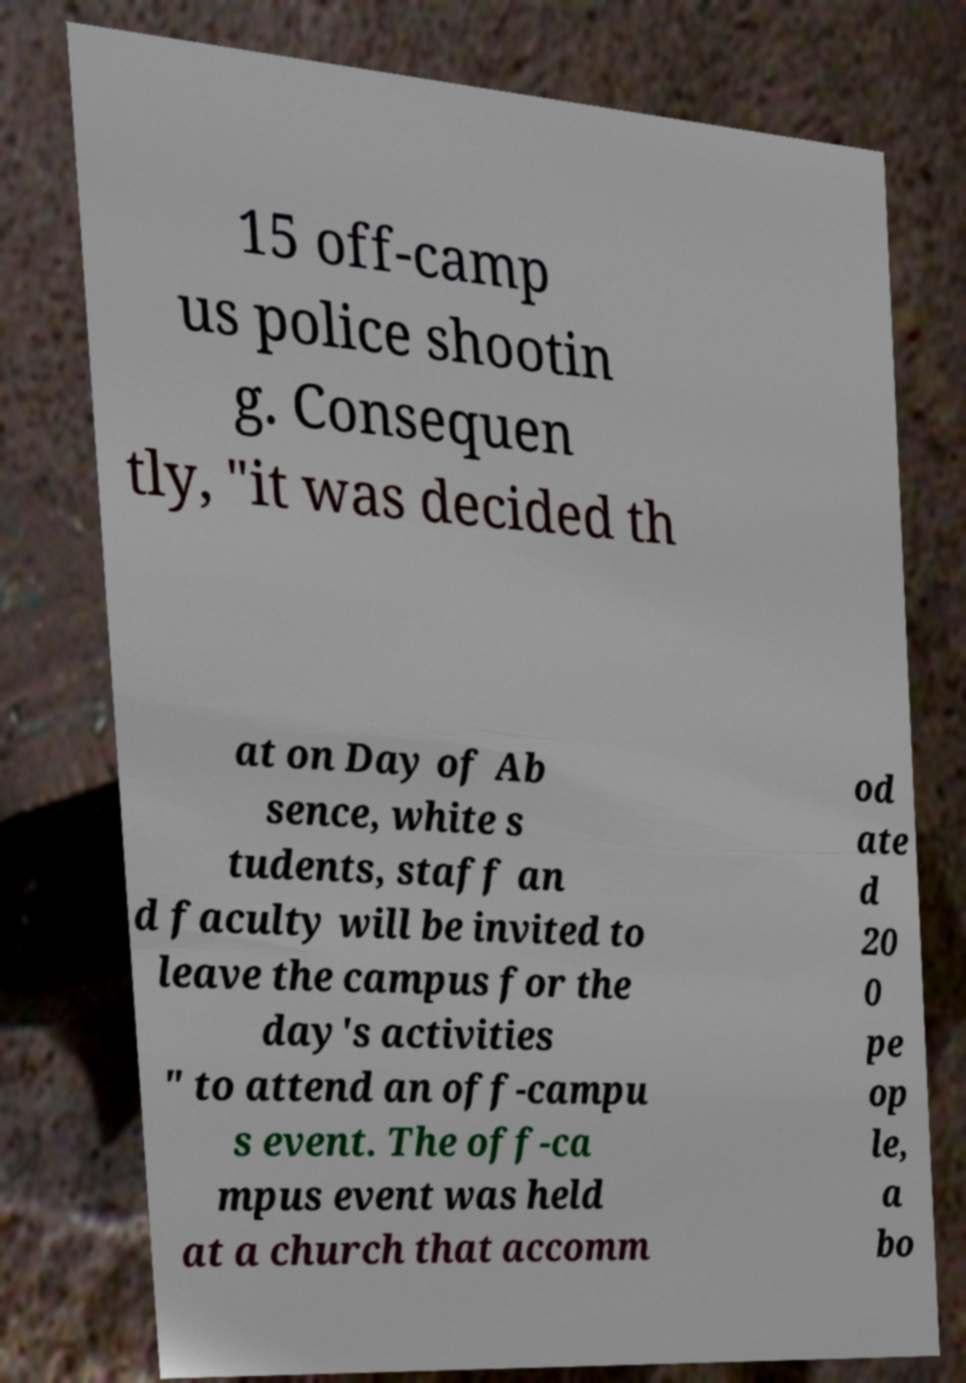I need the written content from this picture converted into text. Can you do that? 15 off-camp us police shootin g. Consequen tly, "it was decided th at on Day of Ab sence, white s tudents, staff an d faculty will be invited to leave the campus for the day's activities " to attend an off-campu s event. The off-ca mpus event was held at a church that accomm od ate d 20 0 pe op le, a bo 